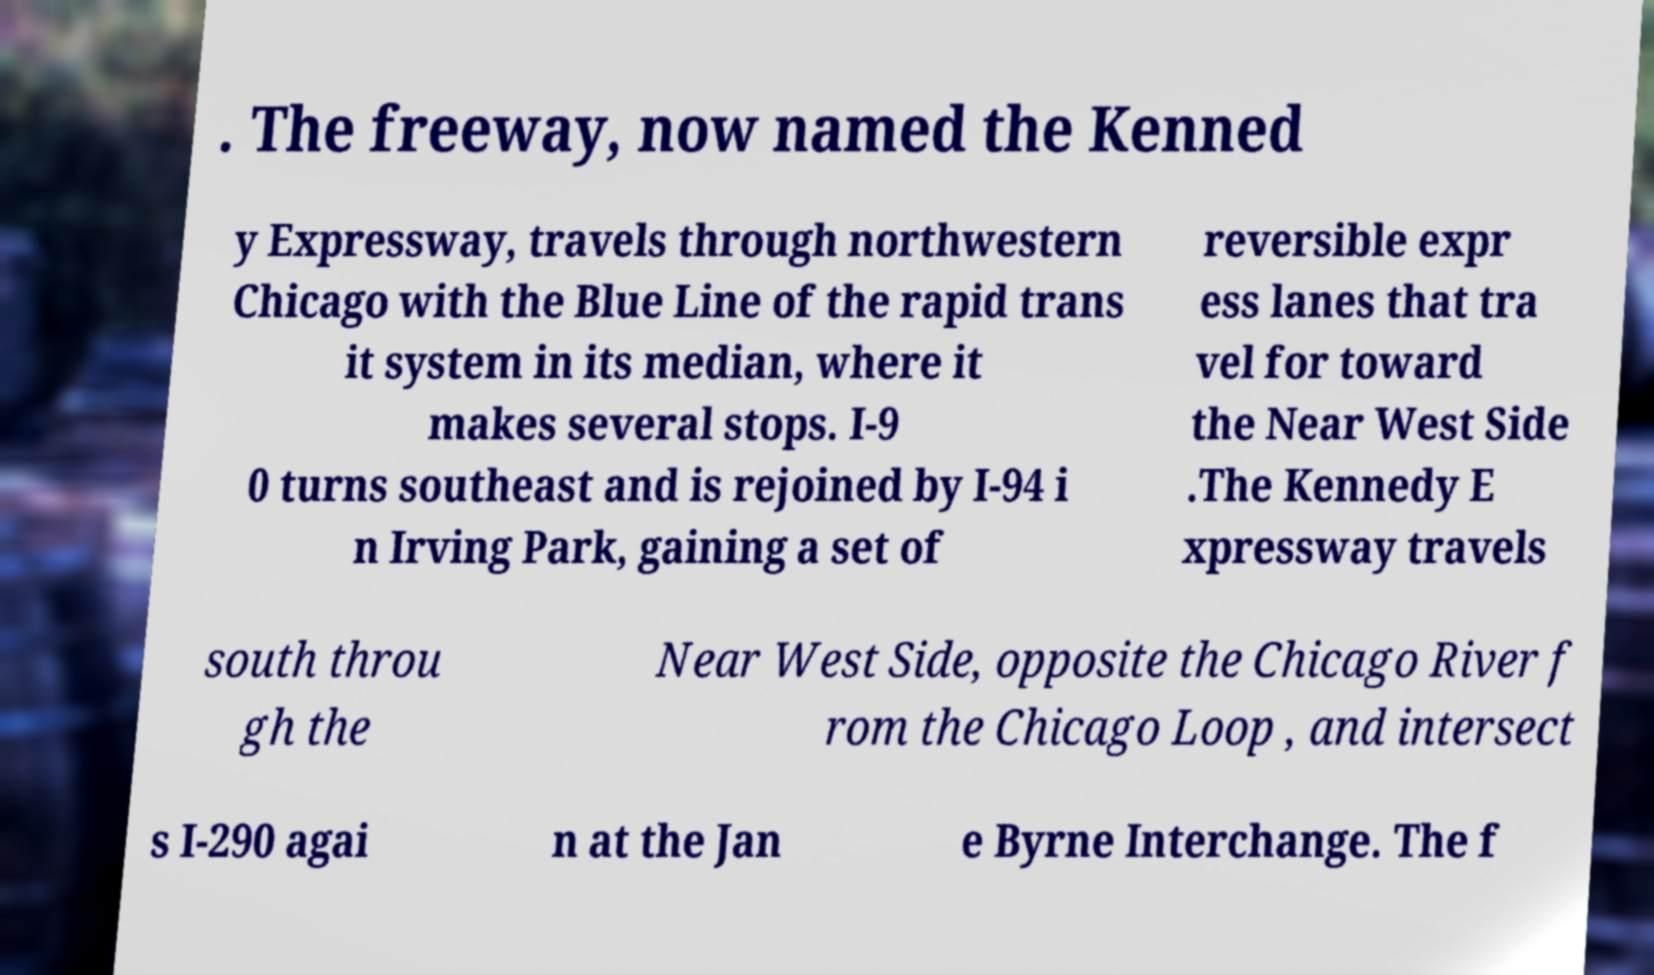Please identify and transcribe the text found in this image. . The freeway, now named the Kenned y Expressway, travels through northwestern Chicago with the Blue Line of the rapid trans it system in its median, where it makes several stops. I-9 0 turns southeast and is rejoined by I-94 i n Irving Park, gaining a set of reversible expr ess lanes that tra vel for toward the Near West Side .The Kennedy E xpressway travels south throu gh the Near West Side, opposite the Chicago River f rom the Chicago Loop , and intersect s I-290 agai n at the Jan e Byrne Interchange. The f 